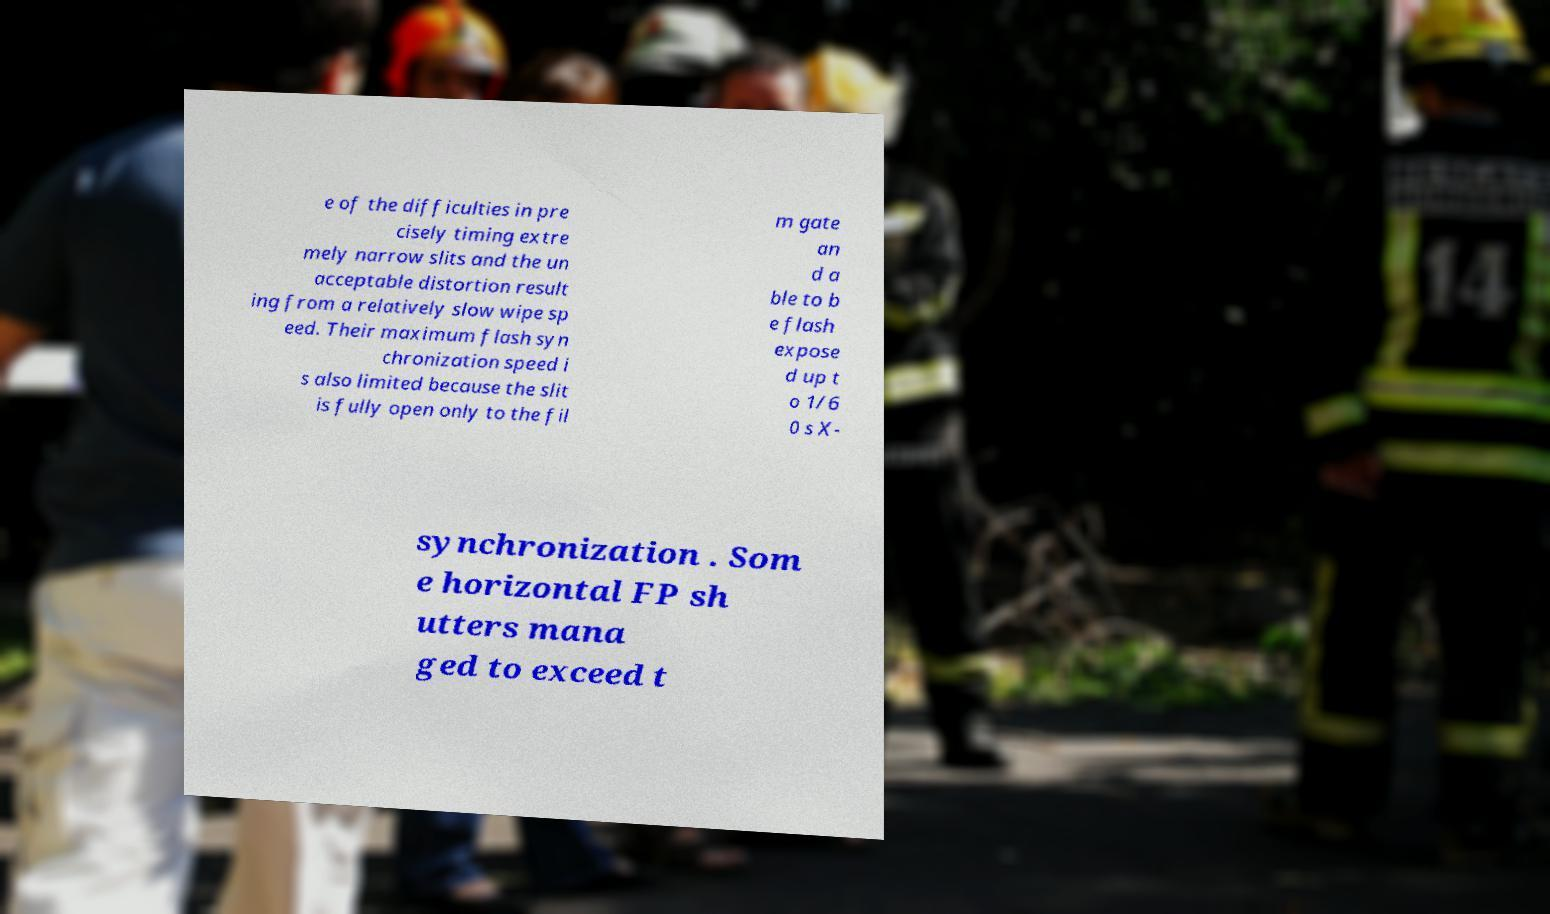Please read and relay the text visible in this image. What does it say? e of the difficulties in pre cisely timing extre mely narrow slits and the un acceptable distortion result ing from a relatively slow wipe sp eed. Their maximum flash syn chronization speed i s also limited because the slit is fully open only to the fil m gate an d a ble to b e flash expose d up t o 1/6 0 s X- synchronization . Som e horizontal FP sh utters mana ged to exceed t 